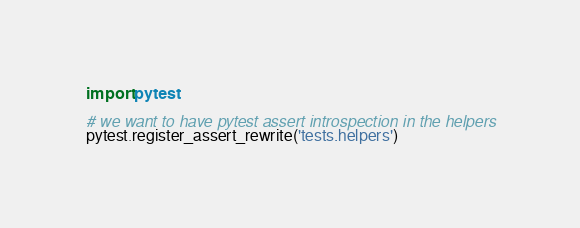<code> <loc_0><loc_0><loc_500><loc_500><_Python_>import pytest

# we want to have pytest assert introspection in the helpers
pytest.register_assert_rewrite('tests.helpers')
</code> 